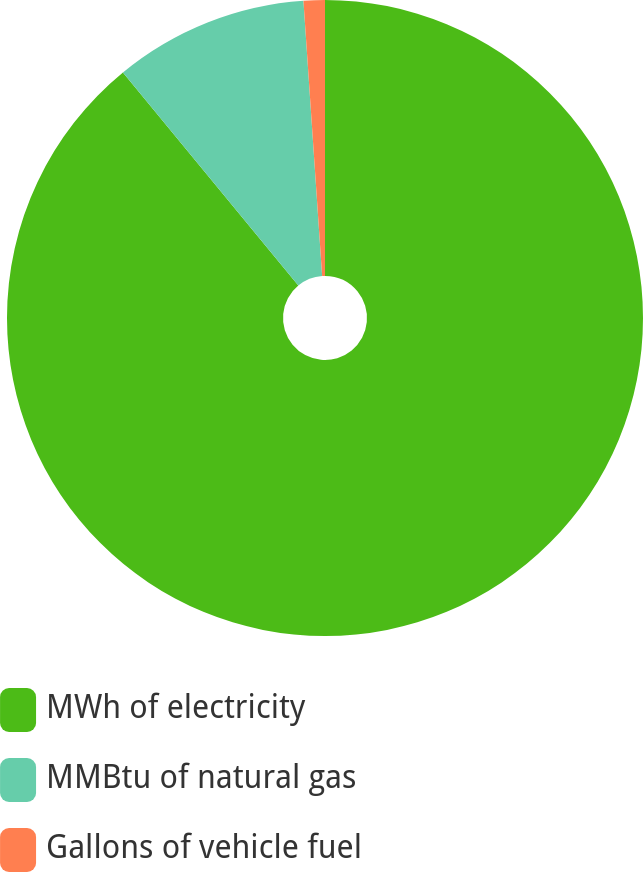Convert chart. <chart><loc_0><loc_0><loc_500><loc_500><pie_chart><fcel>MWh of electricity<fcel>MMBtu of natural gas<fcel>Gallons of vehicle fuel<nl><fcel>89.04%<fcel>9.88%<fcel>1.08%<nl></chart> 